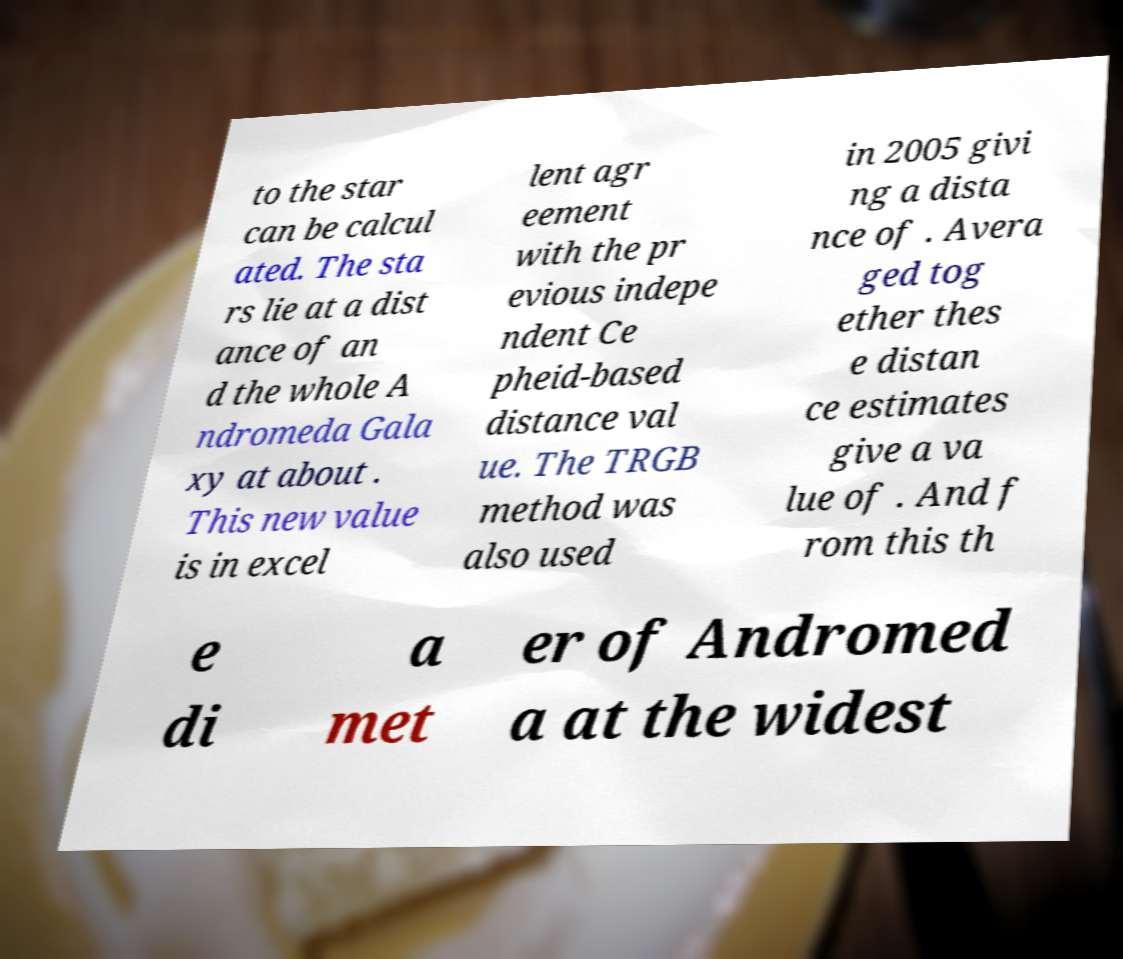I need the written content from this picture converted into text. Can you do that? to the star can be calcul ated. The sta rs lie at a dist ance of an d the whole A ndromeda Gala xy at about . This new value is in excel lent agr eement with the pr evious indepe ndent Ce pheid-based distance val ue. The TRGB method was also used in 2005 givi ng a dista nce of . Avera ged tog ether thes e distan ce estimates give a va lue of . And f rom this th e di a met er of Andromed a at the widest 